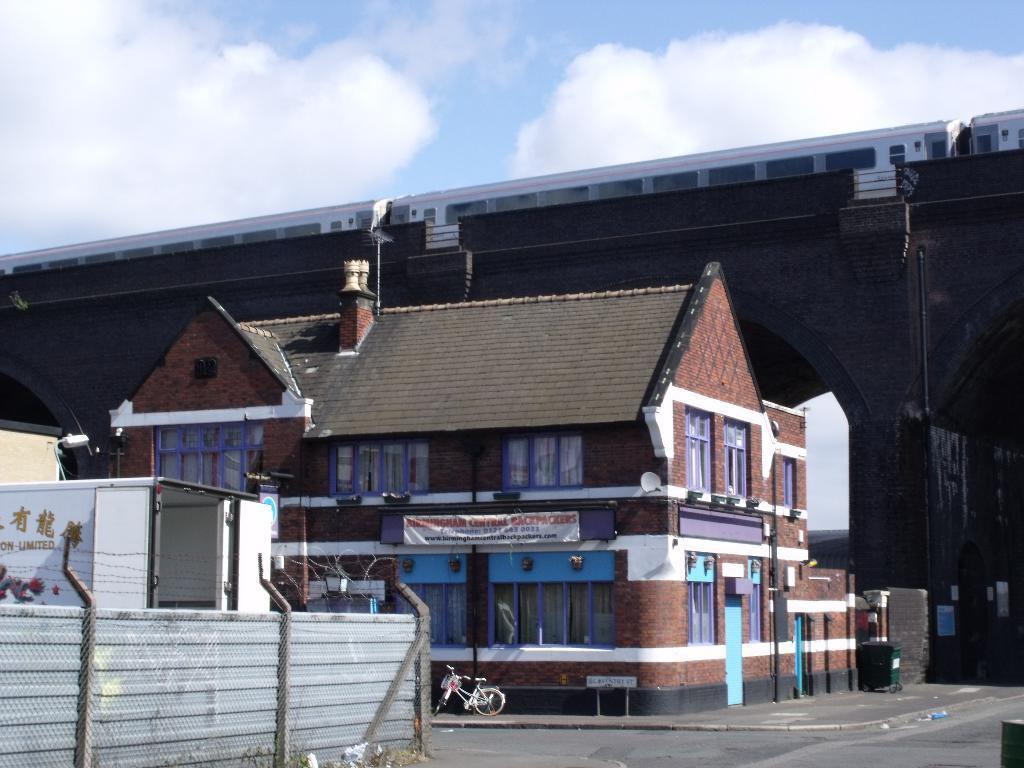Can you describe this image briefly? In this image there are buildings and there is a bicycle parked on the pavement, in front of the building there is a road, behind the building there is a bridge. On the bridge there is a train on the track. In the background there is the sky. 